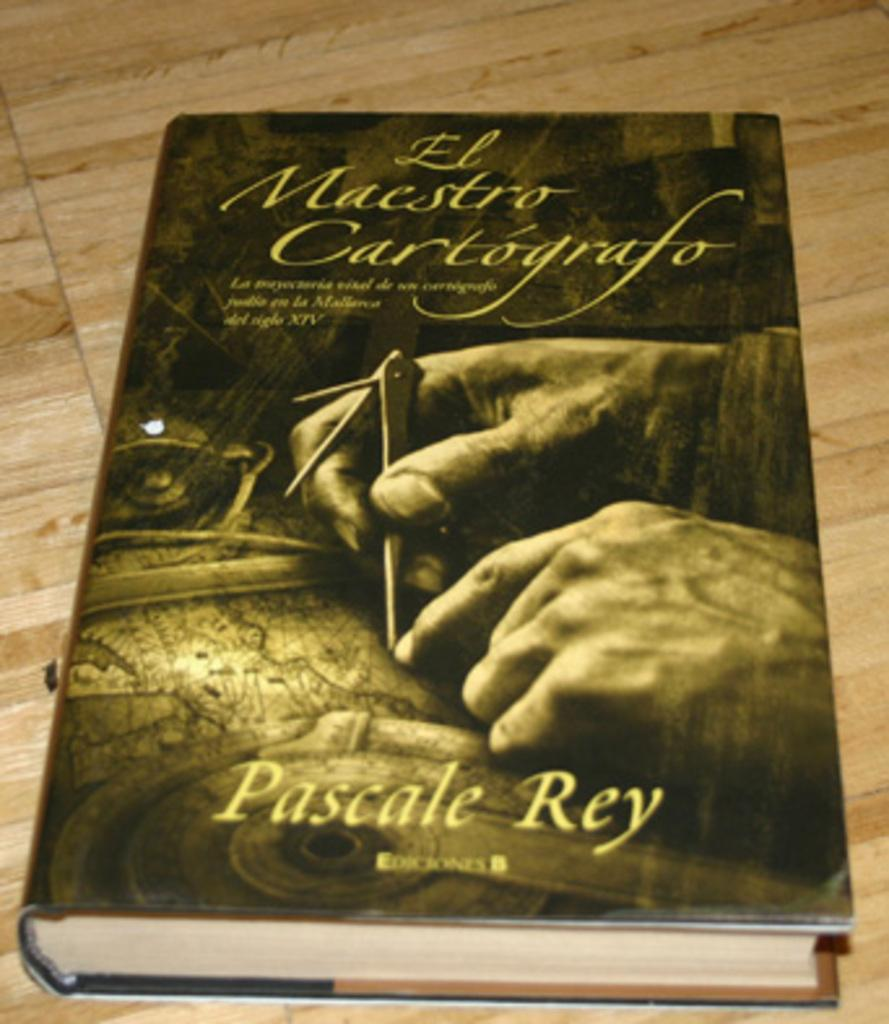<image>
Create a compact narrative representing the image presented. A close up iof a book called El Maestro Cartografo by Pascale Ray has the image of a man marking out a map on its cover. 